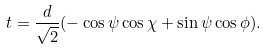<formula> <loc_0><loc_0><loc_500><loc_500>t = \frac { d } { \sqrt { 2 } } ( - \cos \psi \cos \chi + \sin \psi \cos \phi ) .</formula> 